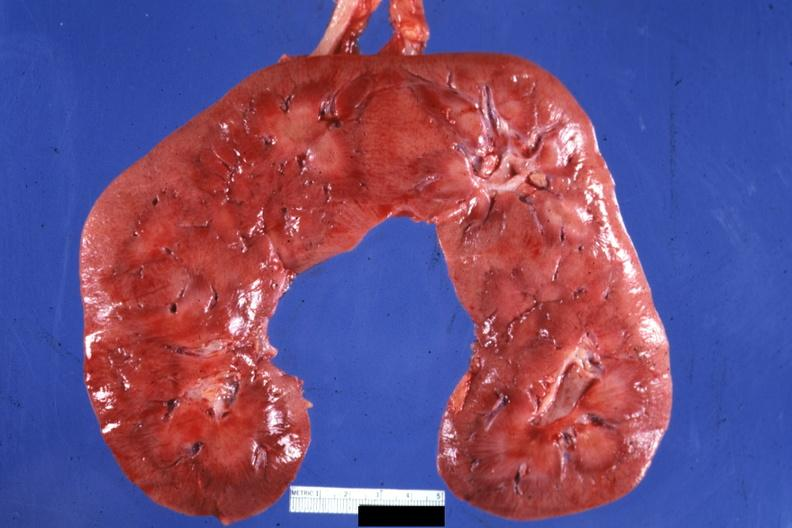s horseshoe kidney present?
Answer the question using a single word or phrase. Yes 